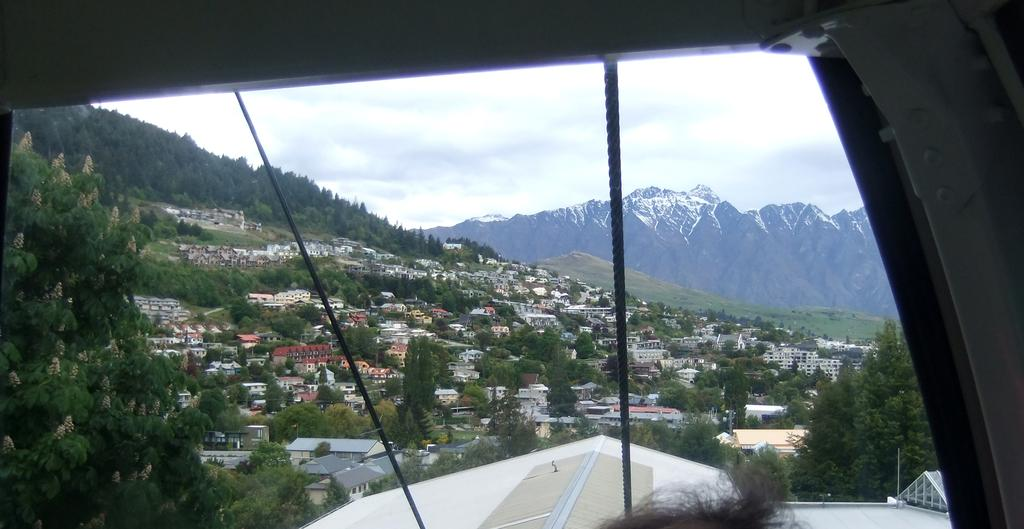What type of structures can be seen in the image? There are roofs of buildings in the image. What colors are the roofs of the buildings? The roofs are white, brown, and cream in color. What type of vegetation is present in the image? There are green trees in the image. What can be seen in the distance in the image? There are mountains visible in the background of the image. What is visible above the buildings and trees in the image? The sky is visible in the background of the image. What type of animal is flying through the sky in the image? There are no animals visible in the sky in the image. 